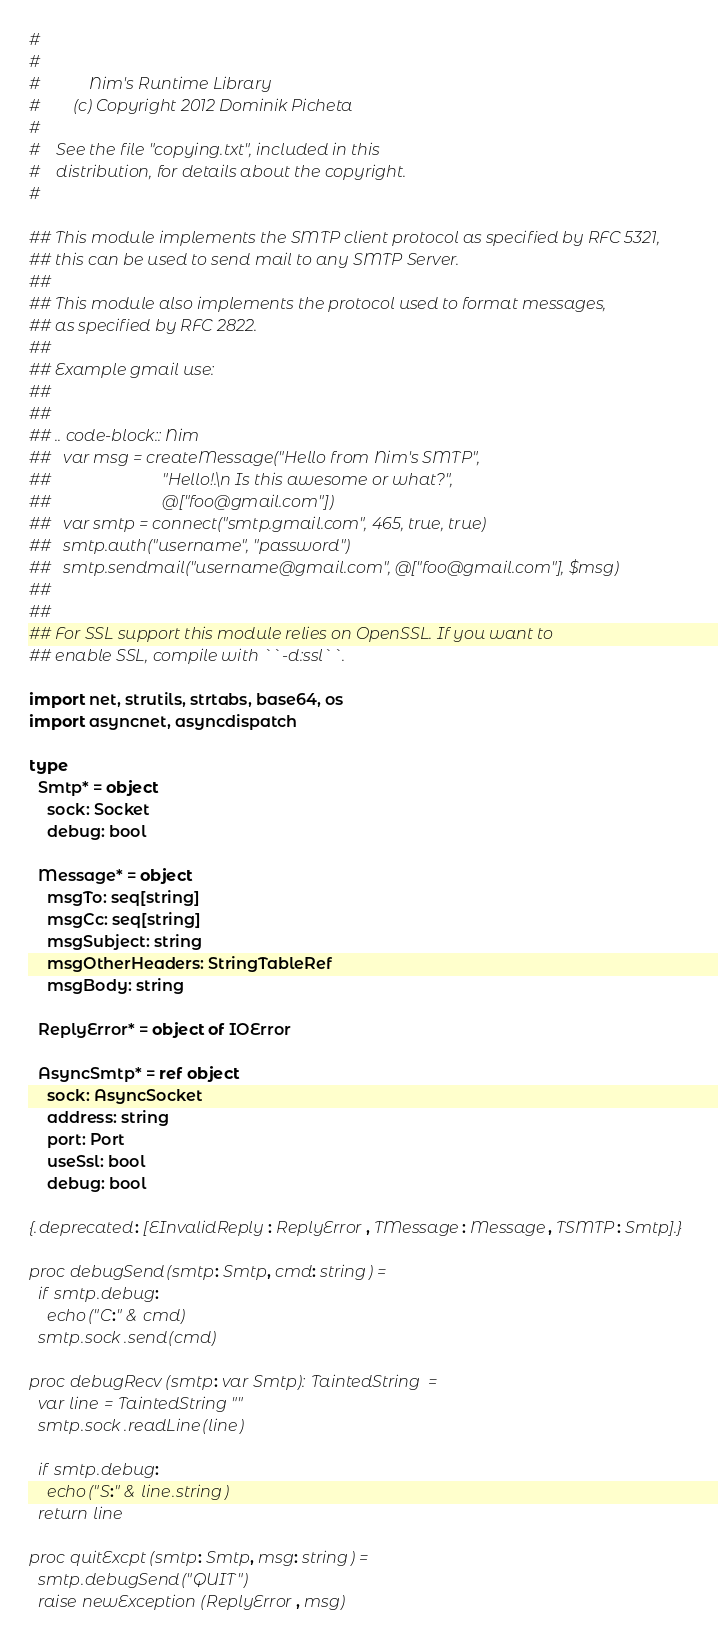Convert code to text. <code><loc_0><loc_0><loc_500><loc_500><_Nim_>#
#
#            Nim's Runtime Library
#        (c) Copyright 2012 Dominik Picheta
#
#    See the file "copying.txt", included in this
#    distribution, for details about the copyright.
#

## This module implements the SMTP client protocol as specified by RFC 5321, 
## this can be used to send mail to any SMTP Server.
## 
## This module also implements the protocol used to format messages, 
## as specified by RFC 2822.
## 
## Example gmail use:
## 
## 
## .. code-block:: Nim
##   var msg = createMessage("Hello from Nim's SMTP", 
##                           "Hello!.\n Is this awesome or what?", 
##                           @["foo@gmail.com"])
##   var smtp = connect("smtp.gmail.com", 465, true, true)
##   smtp.auth("username", "password")
##   smtp.sendmail("username@gmail.com", @["foo@gmail.com"], $msg)
##   
## 
## For SSL support this module relies on OpenSSL. If you want to 
## enable SSL, compile with ``-d:ssl``.

import net, strutils, strtabs, base64, os
import asyncnet, asyncdispatch

type
  Smtp* = object
    sock: Socket
    debug: bool
  
  Message* = object
    msgTo: seq[string]
    msgCc: seq[string]
    msgSubject: string
    msgOtherHeaders: StringTableRef
    msgBody: string
  
  ReplyError* = object of IOError

  AsyncSmtp* = ref object
    sock: AsyncSocket
    address: string
    port: Port
    useSsl: bool
    debug: bool

{.deprecated: [EInvalidReply: ReplyError, TMessage: Message, TSMTP: Smtp].}

proc debugSend(smtp: Smtp, cmd: string) =
  if smtp.debug:
    echo("C:" & cmd)
  smtp.sock.send(cmd)

proc debugRecv(smtp: var Smtp): TaintedString =
  var line = TaintedString""
  smtp.sock.readLine(line)

  if smtp.debug:
    echo("S:" & line.string)
  return line

proc quitExcpt(smtp: Smtp, msg: string) =
  smtp.debugSend("QUIT")
  raise newException(ReplyError, msg)
</code> 